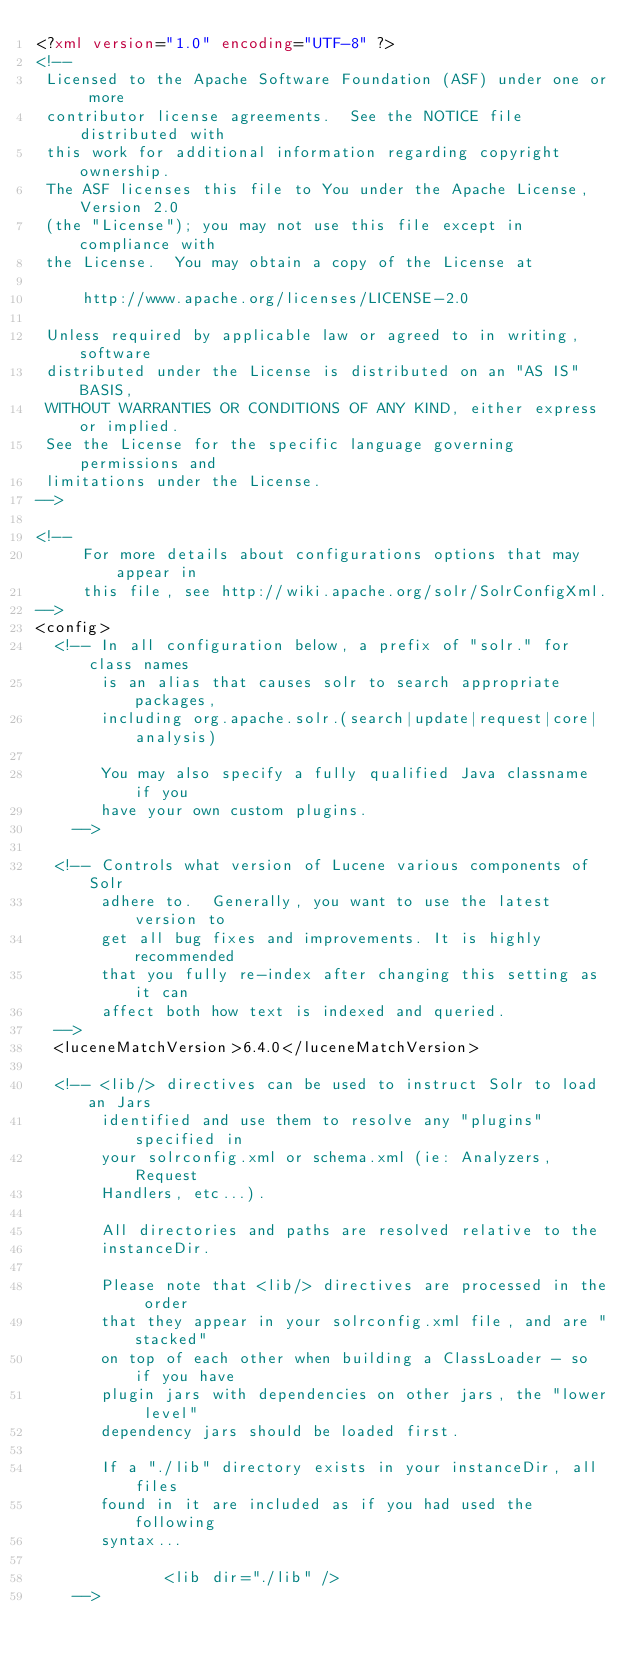Convert code to text. <code><loc_0><loc_0><loc_500><loc_500><_XML_><?xml version="1.0" encoding="UTF-8" ?>
<!--
 Licensed to the Apache Software Foundation (ASF) under one or more
 contributor license agreements.  See the NOTICE file distributed with
 this work for additional information regarding copyright ownership.
 The ASF licenses this file to You under the Apache License, Version 2.0
 (the "License"); you may not use this file except in compliance with
 the License.  You may obtain a copy of the License at

     http://www.apache.org/licenses/LICENSE-2.0

 Unless required by applicable law or agreed to in writing, software
 distributed under the License is distributed on an "AS IS" BASIS,
 WITHOUT WARRANTIES OR CONDITIONS OF ANY KIND, either express or implied.
 See the License for the specific language governing permissions and
 limitations under the License.
-->

<!-- 
     For more details about configurations options that may appear in
     this file, see http://wiki.apache.org/solr/SolrConfigXml. 
-->
<config>
  <!-- In all configuration below, a prefix of "solr." for class names
       is an alias that causes solr to search appropriate packages,
       including org.apache.solr.(search|update|request|core|analysis)

       You may also specify a fully qualified Java classname if you
       have your own custom plugins.
    -->

  <!-- Controls what version of Lucene various components of Solr
       adhere to.  Generally, you want to use the latest version to
       get all bug fixes and improvements. It is highly recommended
       that you fully re-index after changing this setting as it can
       affect both how text is indexed and queried.
  -->
  <luceneMatchVersion>6.4.0</luceneMatchVersion>

  <!-- <lib/> directives can be used to instruct Solr to load an Jars
       identified and use them to resolve any "plugins" specified in
       your solrconfig.xml or schema.xml (ie: Analyzers, Request
       Handlers, etc...).

       All directories and paths are resolved relative to the
       instanceDir.

       Please note that <lib/> directives are processed in the order
       that they appear in your solrconfig.xml file, and are "stacked" 
       on top of each other when building a ClassLoader - so if you have 
       plugin jars with dependencies on other jars, the "lower level" 
       dependency jars should be loaded first.

       If a "./lib" directory exists in your instanceDir, all files
       found in it are included as if you had used the following
       syntax...
       
              <lib dir="./lib" />
    -->
</code> 